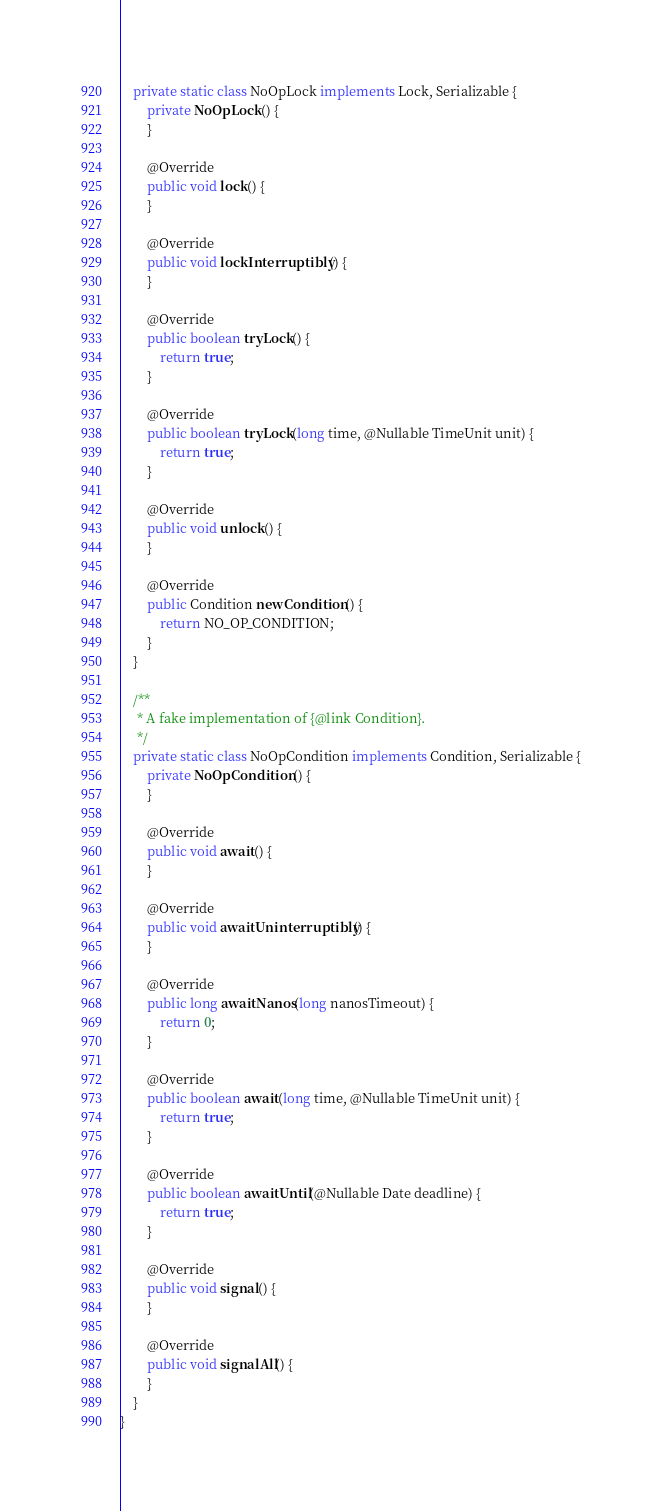Convert code to text. <code><loc_0><loc_0><loc_500><loc_500><_Java_>    private static class NoOpLock implements Lock, Serializable {
        private NoOpLock() {
        }

        @Override
        public void lock() {
        }

        @Override
        public void lockInterruptibly() {
        }

        @Override
        public boolean tryLock() {
            return true;
        }

        @Override
        public boolean tryLock(long time, @Nullable TimeUnit unit) {
            return true;
        }

        @Override
        public void unlock() {
        }

        @Override
        public Condition newCondition() {
            return NO_OP_CONDITION;
        }
    }

    /**
     * A fake implementation of {@link Condition}.
     */
    private static class NoOpCondition implements Condition, Serializable {
        private NoOpCondition() {
        }

        @Override
        public void await() {
        }

        @Override
        public void awaitUninterruptibly() {
        }

        @Override
        public long awaitNanos(long nanosTimeout) {
            return 0;
        }

        @Override
        public boolean await(long time, @Nullable TimeUnit unit) {
            return true;
        }

        @Override
        public boolean awaitUntil(@Nullable Date deadline) {
            return true;
        }

        @Override
        public void signal() {
        }

        @Override
        public void signalAll() {
        }
    }
}
</code> 